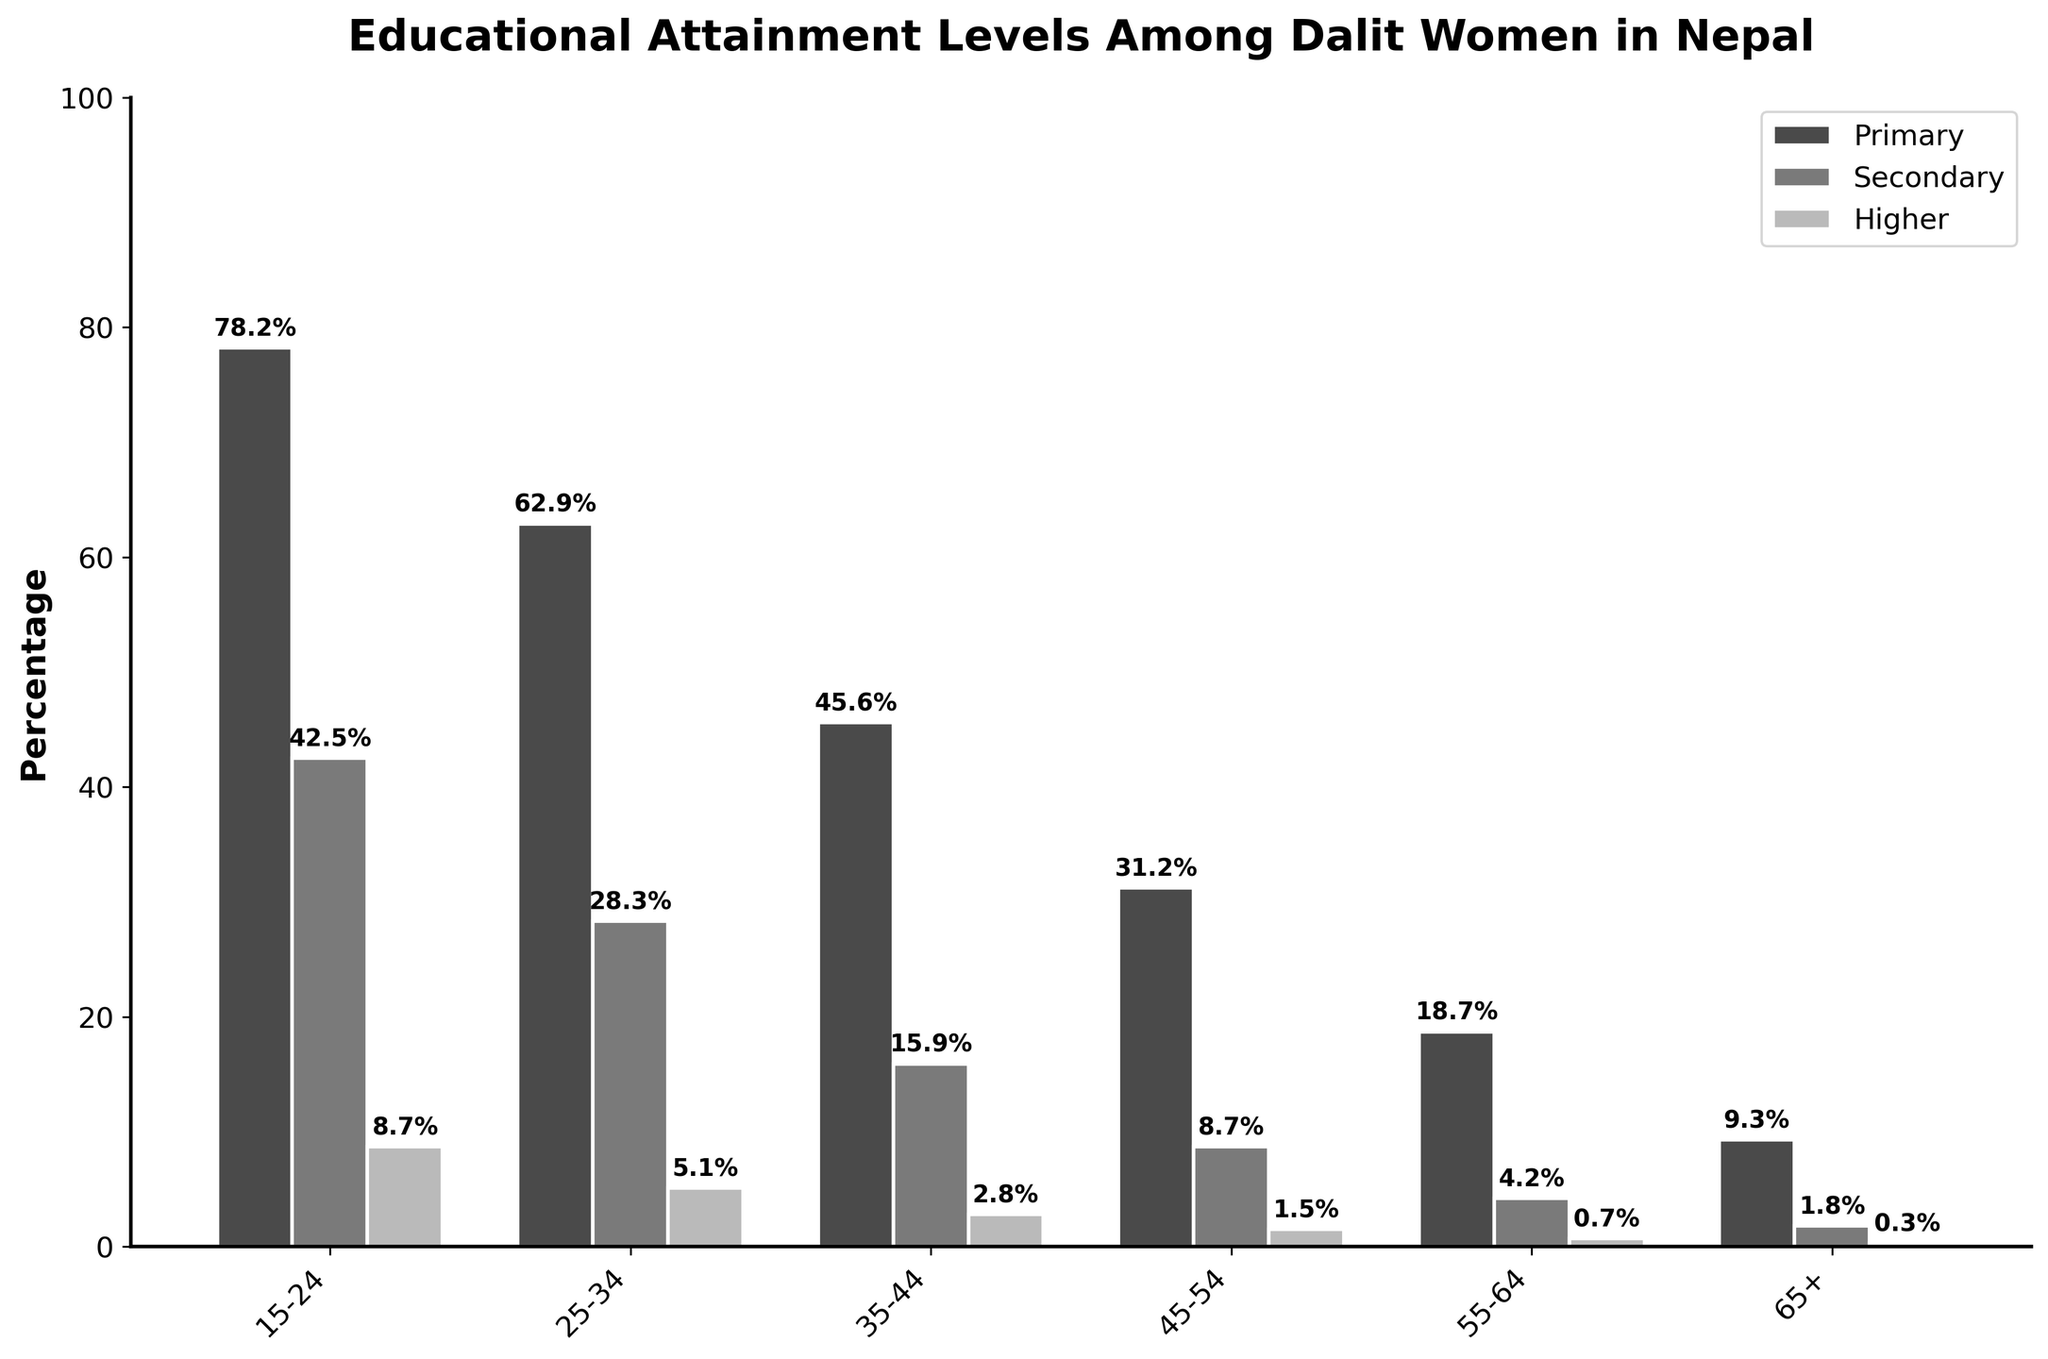What's the percentage difference in higher education attainment between the 15-24 and 65+ age groups? To find the percentage difference, subtract the percentage of higher education attainment for the 65+ age group from that of the 15-24 age group: 8.7% - 0.3% = 8.4%.
Answer: 8.4% Which age group has the highest percentage of women who completed secondary education? By looking at the bar heights, the age group 15-24 shows the highest bar for secondary education compared to other age groups.
Answer: 15-24 Between which two consecutive age groups is the drop in primary education attainment the greatest? We evaluate the percentage differences: 
25-34 to 35-44: 62.9% - 45.6% = 17.3%
35-44 to 45-54: 45.6% - 31.2% = 14.4%
45-54 to 55-64: 31.2% - 18.7% = 12.5%
55-64 to 65+: 18.7% - 9.3% = 9.4%
The greatest drop is between age group 25-34 and 35-44, which is 17.3%.
Answer: 25-34 to 35-44 What is the ratio of women who completed primary education to those who completed higher education in the 45-54 age group? Divide the percentage of primary education completion by the percentage of higher education completion in the 45-54 age group: 31.2% ÷ 1.5% = ~20.8
Answer: 20.8 How does the percentage of secondary education attainment for the 35-44 age group compare to the higher education attainment for the 55-64 age group? Compare the bar heights: The percentage for the 35-44 age group's secondary education is 15.9%, and for the 55-64 age group's higher education, it is 0.7%. 15.9% is significantly higher.
Answer: 15.9% is higher What percentage of women aged 55-64 have completed at least primary education? Sum the percentages of women aged 55-64 who completed primary, secondary, and higher education: 18.7% (primary) + 4.2% (secondary) + 0.7% (higher) = 23.6%
Answer: 23.6% Which educational attainment level sees the most dramatic decrease across age groups? By observing the bar heights, the higher education level starts at 8.7% for 15-24 and drops consistently to 0.3% for age 65+. It shows the most dramatic decrease among educational attainment levels.
Answer: Higher education 